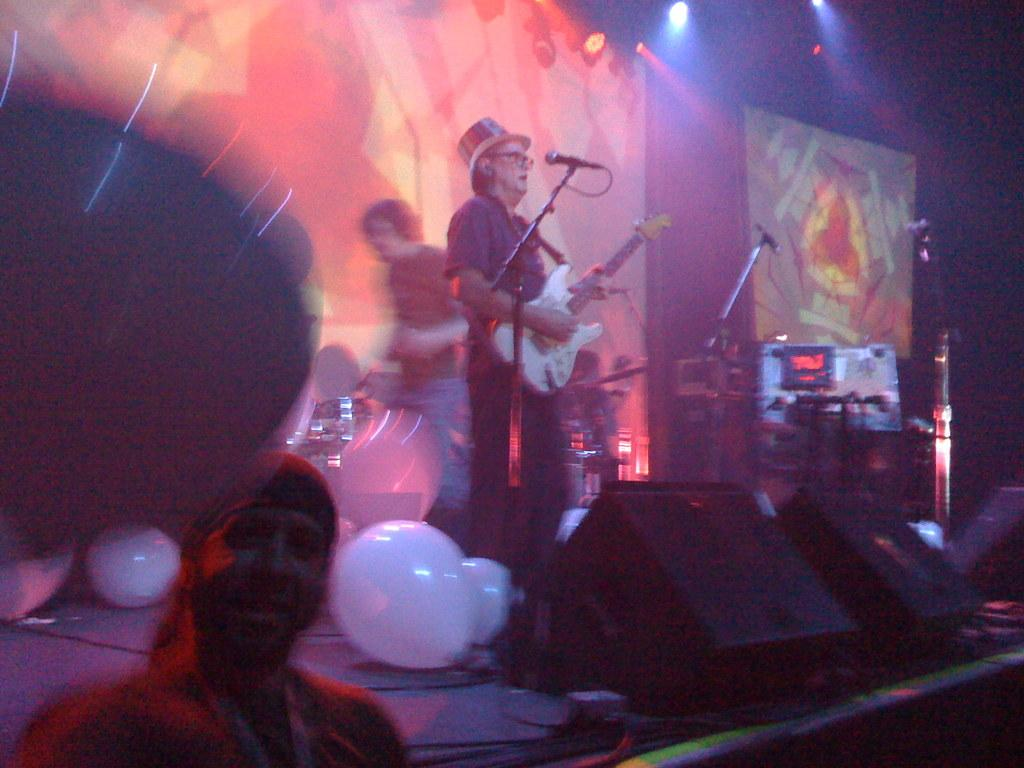What can be seen floating in the image? There are balloons in the image. What is the man in the image holding? The man is holding a guitar in the image. What device is used for amplifying sound in the image? A microphone (mic) is present in the image. What type of equipment is associated with music in the image? There are musical equipment in the image. What type of animal can be seen playing with a pickle in the image? There is no animal or pickle present in the image. Who is the daughter of the man holding the guitar in the image? There is no mention of a daughter in the image or the provided facts. 